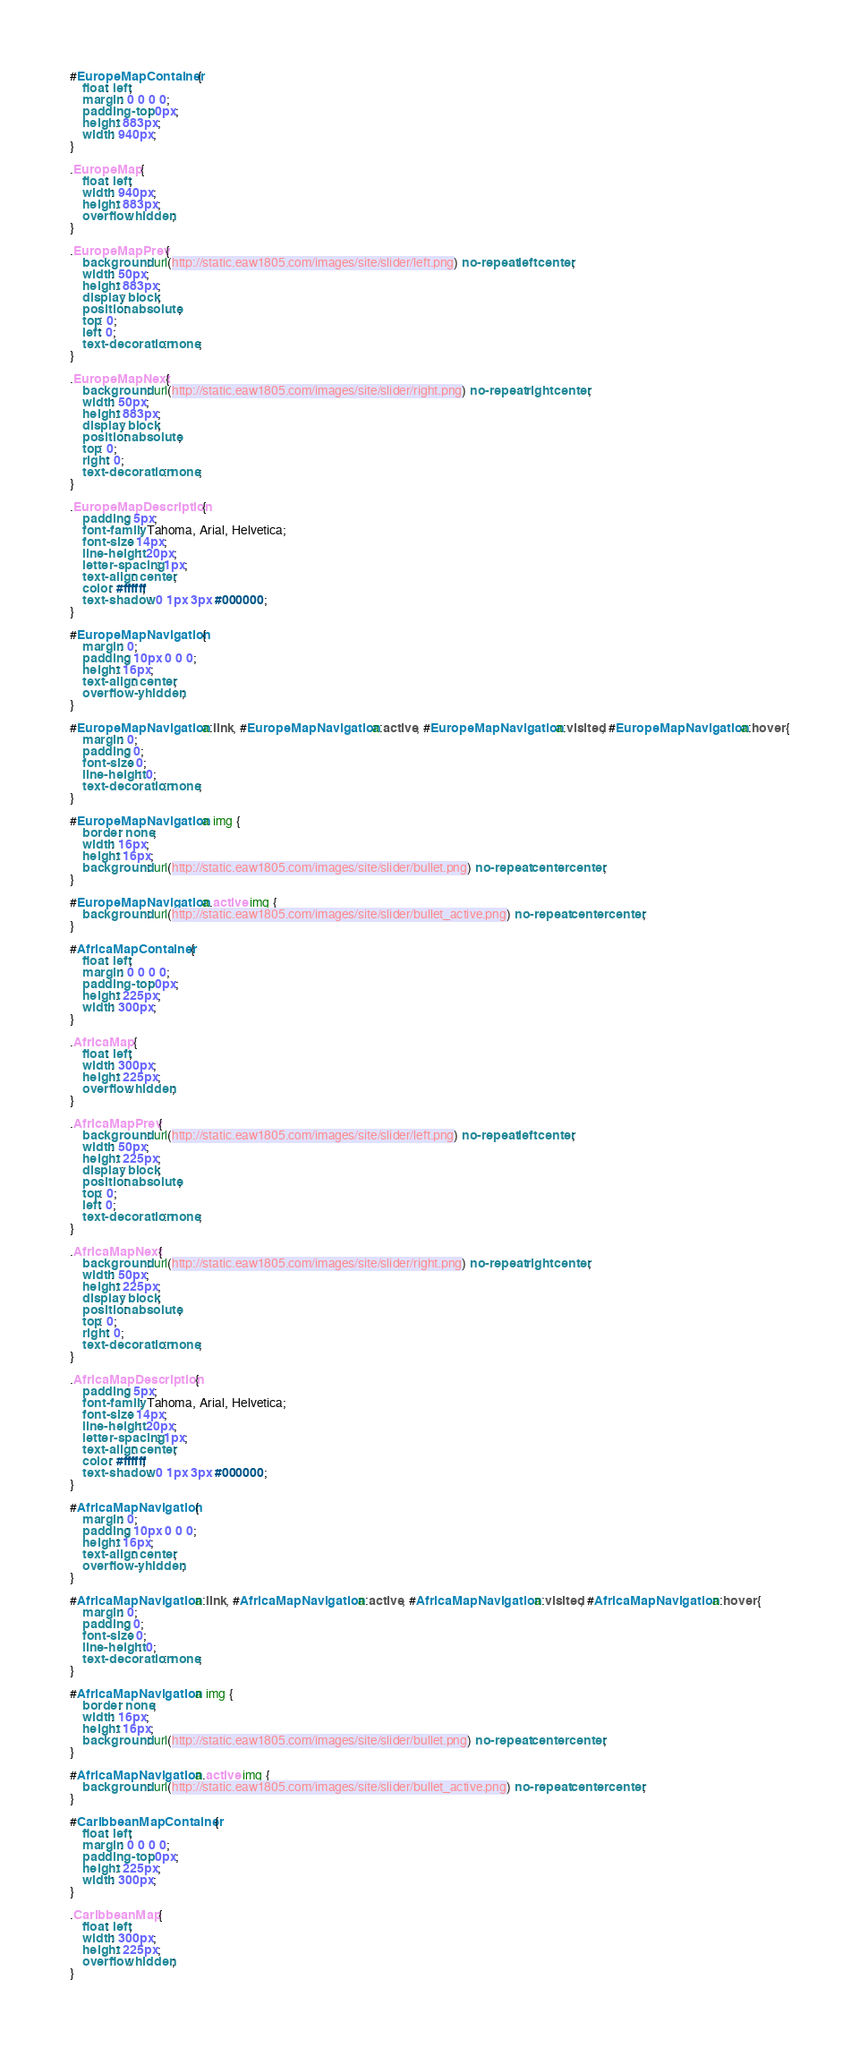Convert code to text. <code><loc_0><loc_0><loc_500><loc_500><_CSS_>#EuropeMapContainer {
    float: left;
    margin: 0 0 0 0;
    padding-top: 0px;
    height: 883px;
    width: 940px;
}

.EuropeMap {
    float: left;
    width: 940px;
    height: 883px;
    overflow: hidden;
}

.EuropeMapPrev {
    background: url(http://static.eaw1805.com/images/site/slider/left.png) no-repeat left center;
    width: 50px;
    height: 883px;
    display: block;
    position: absolute;
    top: 0;
    left: 0;
    text-decoration: none;
}

.EuropeMapNext {
    background: url(http://static.eaw1805.com/images/site/slider/right.png) no-repeat right center;
    width: 50px;
    height: 883px;
    display: block;
    position: absolute;
    top: 0;
    right: 0;
    text-decoration: none;
}

.EuropeMapDescription {
    padding: 5px;
    font-family: Tahoma, Arial, Helvetica;
    font-size: 14px;
    line-height: 20px;
    letter-spacing: 1px;
    text-align: center;
    color: #ffffff;
    text-shadow: 0 1px 3px #000000;
}

#EuropeMapNavigation {
    margin: 0;
    padding: 10px 0 0 0;
    height: 16px;
    text-align: center;
    overflow-y: hidden;
}

#EuropeMapNavigation a:link, #EuropeMapNavigation a:active, #EuropeMapNavigation a:visited, #EuropeMapNavigation a:hover {
    margin: 0;
    padding: 0;
    font-size: 0;
    line-height: 0;
    text-decoration: none;
}

#EuropeMapNavigation a img {
    border: none;
    width: 16px;
    height: 16px;
    background: url(http://static.eaw1805.com/images/site/slider/bullet.png) no-repeat center center;
}

#EuropeMapNavigation a.active img {
    background: url(http://static.eaw1805.com/images/site/slider/bullet_active.png) no-repeat center center;
}

#AfricaMapContainer {
    float: left;
    margin: 0 0 0 0;
    padding-top: 0px;
    height: 225px;
    width: 300px;
}

.AfricaMap {
    float: left;
    width: 300px;
    height: 225px;
    overflow: hidden;
}

.AfricaMapPrev {
    background: url(http://static.eaw1805.com/images/site/slider/left.png) no-repeat left center;
    width: 50px;
    height: 225px;
    display: block;
    position: absolute;
    top: 0;
    left: 0;
    text-decoration: none;
}

.AfricaMapNext {
    background: url(http://static.eaw1805.com/images/site/slider/right.png) no-repeat right center;
    width: 50px;
    height: 225px;
    display: block;
    position: absolute;
    top: 0;
    right: 0;
    text-decoration: none;
}

.AfricaMapDescription {
    padding: 5px;
    font-family: Tahoma, Arial, Helvetica;
    font-size: 14px;
    line-height: 20px;
    letter-spacing: 1px;
    text-align: center;
    color: #ffffff;
    text-shadow: 0 1px 3px #000000;
}

#AfricaMapNavigation {
    margin: 0;
    padding: 10px 0 0 0;
    height: 16px;
    text-align: center;
    overflow-y: hidden;
}

#AfricaMapNavigation a:link, #AfricaMapNavigation a:active, #AfricaMapNavigation a:visited, #AfricaMapNavigation a:hover {
    margin: 0;
    padding: 0;
    font-size: 0;
    line-height: 0;
    text-decoration: none;
}

#AfricaMapNavigation a img {
    border: none;
    width: 16px;
    height: 16px;
    background: url(http://static.eaw1805.com/images/site/slider/bullet.png) no-repeat center center;
}

#AfricaMapNavigation a.active img {
    background: url(http://static.eaw1805.com/images/site/slider/bullet_active.png) no-repeat center center;
}

#CaribbeanMapContainer {
    float: left;
    margin: 0 0 0 0;
    padding-top: 0px;
    height: 225px;
    width: 300px;
}

.CaribbeanMap {
    float: left;
    width: 300px;
    height: 225px;
    overflow: hidden;
}
</code> 